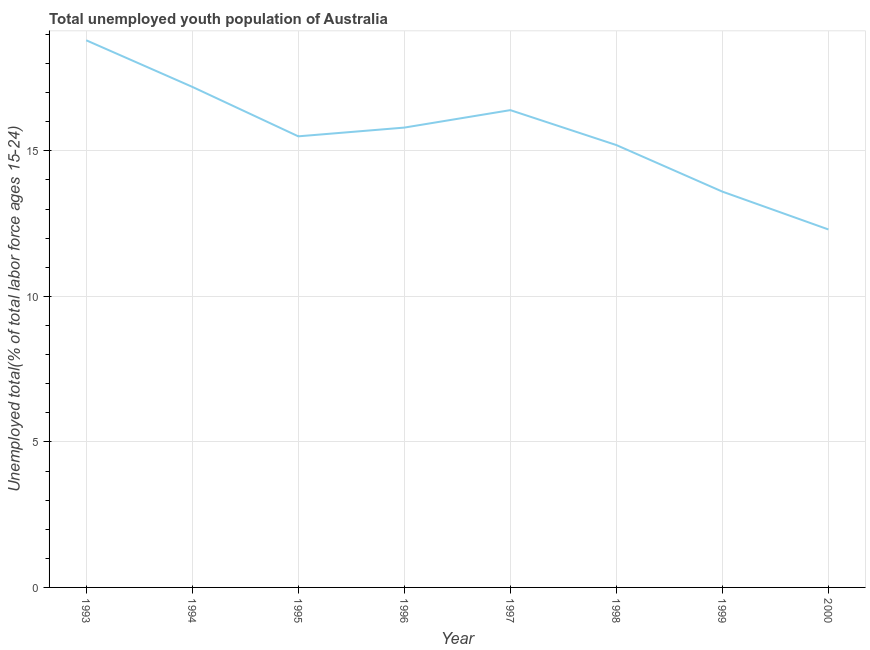What is the unemployed youth in 1995?
Make the answer very short. 15.5. Across all years, what is the maximum unemployed youth?
Your response must be concise. 18.8. Across all years, what is the minimum unemployed youth?
Make the answer very short. 12.3. In which year was the unemployed youth maximum?
Provide a short and direct response. 1993. What is the sum of the unemployed youth?
Ensure brevity in your answer.  124.8. What is the difference between the unemployed youth in 1999 and 2000?
Offer a very short reply. 1.3. What is the average unemployed youth per year?
Keep it short and to the point. 15.6. What is the median unemployed youth?
Make the answer very short. 15.65. In how many years, is the unemployed youth greater than 12 %?
Provide a succinct answer. 8. Do a majority of the years between 1997 and 2000 (inclusive) have unemployed youth greater than 4 %?
Keep it short and to the point. Yes. What is the ratio of the unemployed youth in 1993 to that in 1998?
Offer a very short reply. 1.24. What is the difference between the highest and the second highest unemployed youth?
Offer a terse response. 1.6. What is the difference between the highest and the lowest unemployed youth?
Make the answer very short. 6.5. In how many years, is the unemployed youth greater than the average unemployed youth taken over all years?
Make the answer very short. 4. Does the unemployed youth monotonically increase over the years?
Give a very brief answer. No. How many years are there in the graph?
Offer a very short reply. 8. Are the values on the major ticks of Y-axis written in scientific E-notation?
Provide a succinct answer. No. Does the graph contain any zero values?
Provide a succinct answer. No. Does the graph contain grids?
Ensure brevity in your answer.  Yes. What is the title of the graph?
Keep it short and to the point. Total unemployed youth population of Australia. What is the label or title of the X-axis?
Ensure brevity in your answer.  Year. What is the label or title of the Y-axis?
Your answer should be compact. Unemployed total(% of total labor force ages 15-24). What is the Unemployed total(% of total labor force ages 15-24) in 1993?
Provide a succinct answer. 18.8. What is the Unemployed total(% of total labor force ages 15-24) of 1994?
Offer a very short reply. 17.2. What is the Unemployed total(% of total labor force ages 15-24) in 1996?
Your response must be concise. 15.8. What is the Unemployed total(% of total labor force ages 15-24) of 1997?
Provide a short and direct response. 16.4. What is the Unemployed total(% of total labor force ages 15-24) of 1998?
Give a very brief answer. 15.2. What is the Unemployed total(% of total labor force ages 15-24) of 1999?
Give a very brief answer. 13.6. What is the Unemployed total(% of total labor force ages 15-24) in 2000?
Your answer should be very brief. 12.3. What is the difference between the Unemployed total(% of total labor force ages 15-24) in 1993 and 1994?
Keep it short and to the point. 1.6. What is the difference between the Unemployed total(% of total labor force ages 15-24) in 1993 and 1997?
Provide a succinct answer. 2.4. What is the difference between the Unemployed total(% of total labor force ages 15-24) in 1993 and 1999?
Your answer should be compact. 5.2. What is the difference between the Unemployed total(% of total labor force ages 15-24) in 1993 and 2000?
Your answer should be compact. 6.5. What is the difference between the Unemployed total(% of total labor force ages 15-24) in 1994 and 1996?
Provide a succinct answer. 1.4. What is the difference between the Unemployed total(% of total labor force ages 15-24) in 1994 and 1997?
Your answer should be compact. 0.8. What is the difference between the Unemployed total(% of total labor force ages 15-24) in 1994 and 1998?
Provide a short and direct response. 2. What is the difference between the Unemployed total(% of total labor force ages 15-24) in 1994 and 1999?
Ensure brevity in your answer.  3.6. What is the difference between the Unemployed total(% of total labor force ages 15-24) in 1995 and 1996?
Ensure brevity in your answer.  -0.3. What is the difference between the Unemployed total(% of total labor force ages 15-24) in 1995 and 1999?
Provide a succinct answer. 1.9. What is the difference between the Unemployed total(% of total labor force ages 15-24) in 1996 and 1998?
Your answer should be very brief. 0.6. What is the difference between the Unemployed total(% of total labor force ages 15-24) in 1996 and 1999?
Your answer should be very brief. 2.2. What is the difference between the Unemployed total(% of total labor force ages 15-24) in 1997 and 1999?
Keep it short and to the point. 2.8. What is the difference between the Unemployed total(% of total labor force ages 15-24) in 1997 and 2000?
Your response must be concise. 4.1. What is the difference between the Unemployed total(% of total labor force ages 15-24) in 1998 and 1999?
Give a very brief answer. 1.6. What is the difference between the Unemployed total(% of total labor force ages 15-24) in 1999 and 2000?
Your response must be concise. 1.3. What is the ratio of the Unemployed total(% of total labor force ages 15-24) in 1993 to that in 1994?
Make the answer very short. 1.09. What is the ratio of the Unemployed total(% of total labor force ages 15-24) in 1993 to that in 1995?
Your answer should be very brief. 1.21. What is the ratio of the Unemployed total(% of total labor force ages 15-24) in 1993 to that in 1996?
Your answer should be compact. 1.19. What is the ratio of the Unemployed total(% of total labor force ages 15-24) in 1993 to that in 1997?
Your answer should be compact. 1.15. What is the ratio of the Unemployed total(% of total labor force ages 15-24) in 1993 to that in 1998?
Make the answer very short. 1.24. What is the ratio of the Unemployed total(% of total labor force ages 15-24) in 1993 to that in 1999?
Offer a very short reply. 1.38. What is the ratio of the Unemployed total(% of total labor force ages 15-24) in 1993 to that in 2000?
Keep it short and to the point. 1.53. What is the ratio of the Unemployed total(% of total labor force ages 15-24) in 1994 to that in 1995?
Your answer should be compact. 1.11. What is the ratio of the Unemployed total(% of total labor force ages 15-24) in 1994 to that in 1996?
Ensure brevity in your answer.  1.09. What is the ratio of the Unemployed total(% of total labor force ages 15-24) in 1994 to that in 1997?
Your answer should be compact. 1.05. What is the ratio of the Unemployed total(% of total labor force ages 15-24) in 1994 to that in 1998?
Provide a short and direct response. 1.13. What is the ratio of the Unemployed total(% of total labor force ages 15-24) in 1994 to that in 1999?
Your answer should be very brief. 1.26. What is the ratio of the Unemployed total(% of total labor force ages 15-24) in 1994 to that in 2000?
Offer a terse response. 1.4. What is the ratio of the Unemployed total(% of total labor force ages 15-24) in 1995 to that in 1997?
Provide a succinct answer. 0.94. What is the ratio of the Unemployed total(% of total labor force ages 15-24) in 1995 to that in 1999?
Your answer should be compact. 1.14. What is the ratio of the Unemployed total(% of total labor force ages 15-24) in 1995 to that in 2000?
Offer a very short reply. 1.26. What is the ratio of the Unemployed total(% of total labor force ages 15-24) in 1996 to that in 1997?
Provide a short and direct response. 0.96. What is the ratio of the Unemployed total(% of total labor force ages 15-24) in 1996 to that in 1998?
Provide a short and direct response. 1.04. What is the ratio of the Unemployed total(% of total labor force ages 15-24) in 1996 to that in 1999?
Your answer should be very brief. 1.16. What is the ratio of the Unemployed total(% of total labor force ages 15-24) in 1996 to that in 2000?
Provide a short and direct response. 1.28. What is the ratio of the Unemployed total(% of total labor force ages 15-24) in 1997 to that in 1998?
Provide a short and direct response. 1.08. What is the ratio of the Unemployed total(% of total labor force ages 15-24) in 1997 to that in 1999?
Your answer should be compact. 1.21. What is the ratio of the Unemployed total(% of total labor force ages 15-24) in 1997 to that in 2000?
Offer a very short reply. 1.33. What is the ratio of the Unemployed total(% of total labor force ages 15-24) in 1998 to that in 1999?
Your answer should be very brief. 1.12. What is the ratio of the Unemployed total(% of total labor force ages 15-24) in 1998 to that in 2000?
Offer a terse response. 1.24. What is the ratio of the Unemployed total(% of total labor force ages 15-24) in 1999 to that in 2000?
Your answer should be compact. 1.11. 